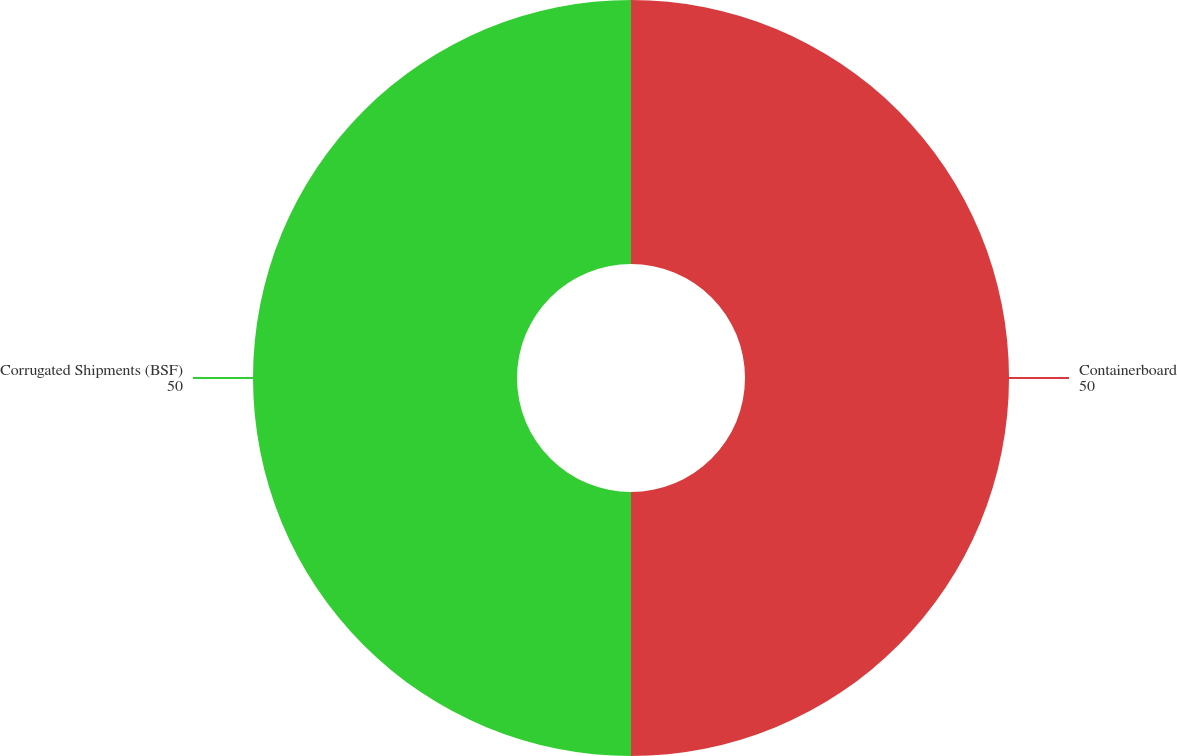<chart> <loc_0><loc_0><loc_500><loc_500><pie_chart><fcel>Containerboard<fcel>Corrugated Shipments (BSF)<nl><fcel>50.0%<fcel>50.0%<nl></chart> 